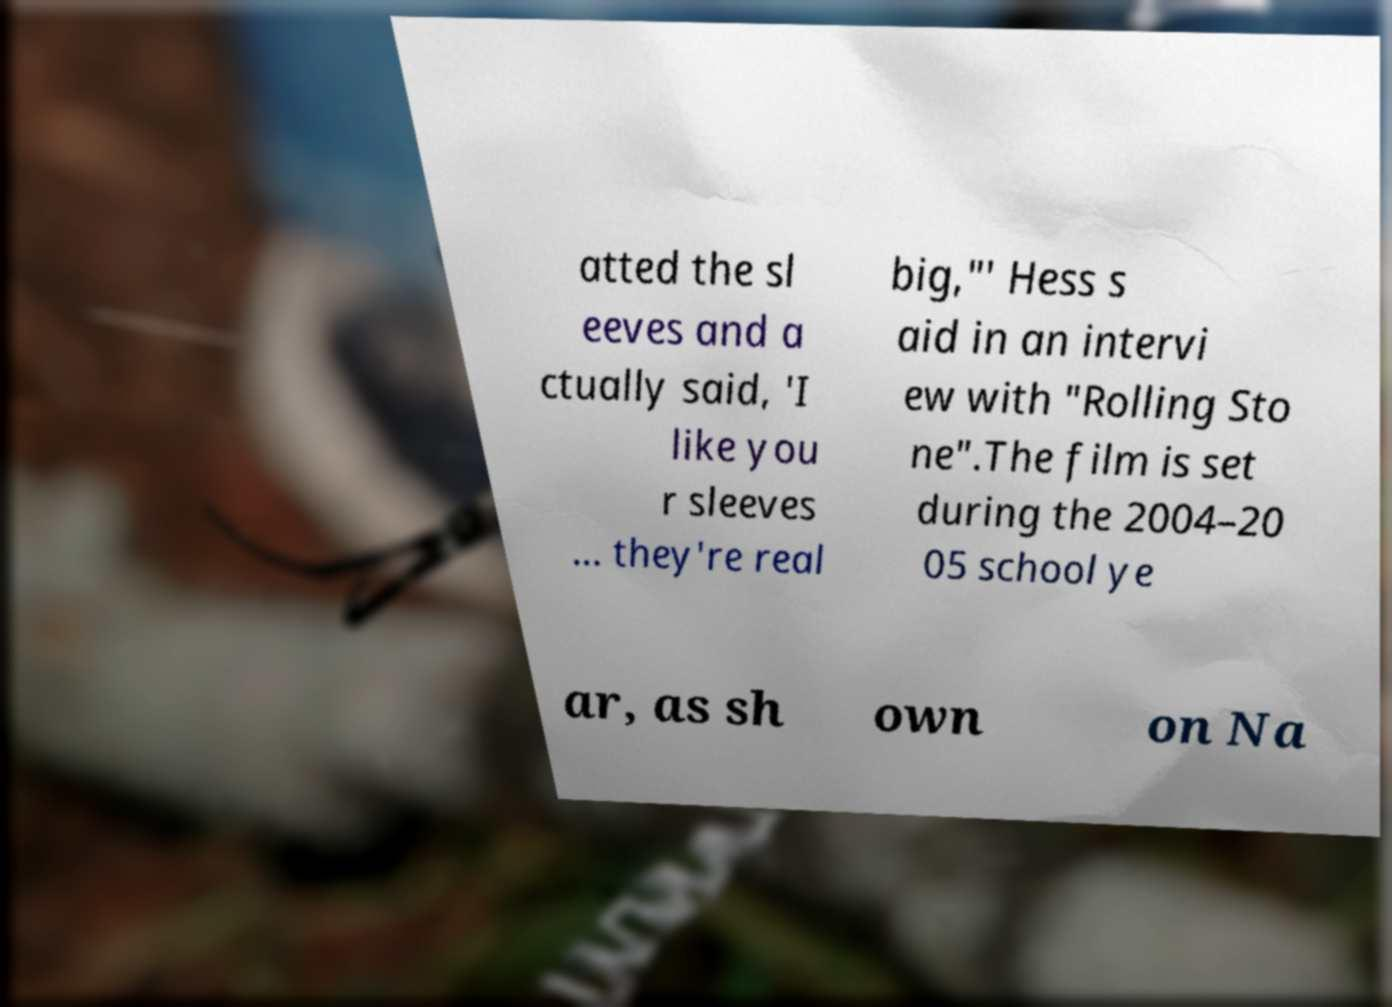There's text embedded in this image that I need extracted. Can you transcribe it verbatim? atted the sl eeves and a ctually said, 'I like you r sleeves ... they're real big,"' Hess s aid in an intervi ew with "Rolling Sto ne".The film is set during the 2004–20 05 school ye ar, as sh own on Na 